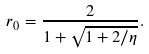<formula> <loc_0><loc_0><loc_500><loc_500>\ r _ { 0 } = \frac { 2 } { 1 + \sqrt { 1 + 2 / \eta } } .</formula> 